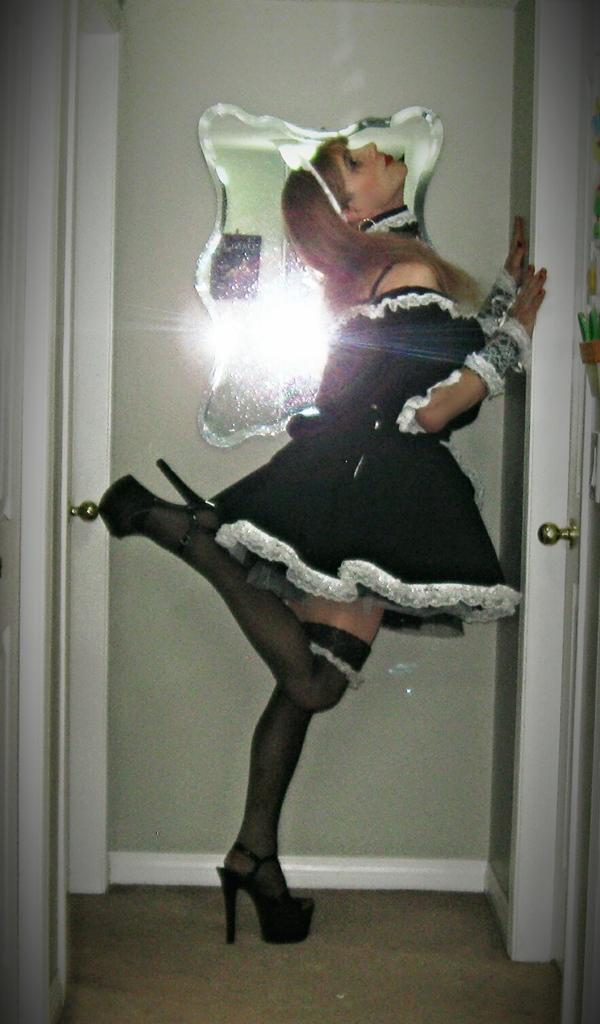Please provide a concise description of this image. In this image there is a lady wearing a black dress and heels standing with one leg, on a floor in the background there is a door for that door there is a mirror. 